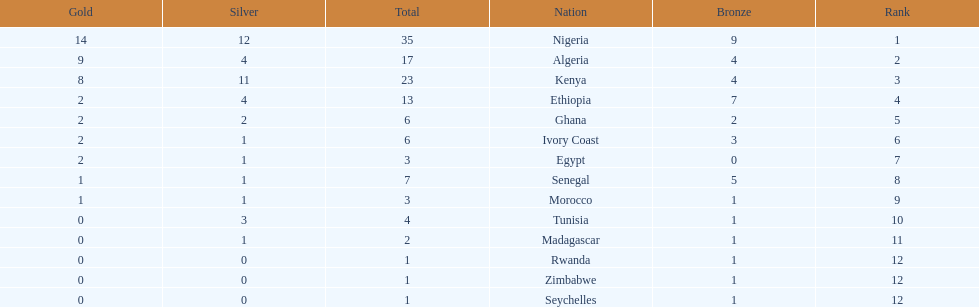How many silver medals did kenya earn? 11. 